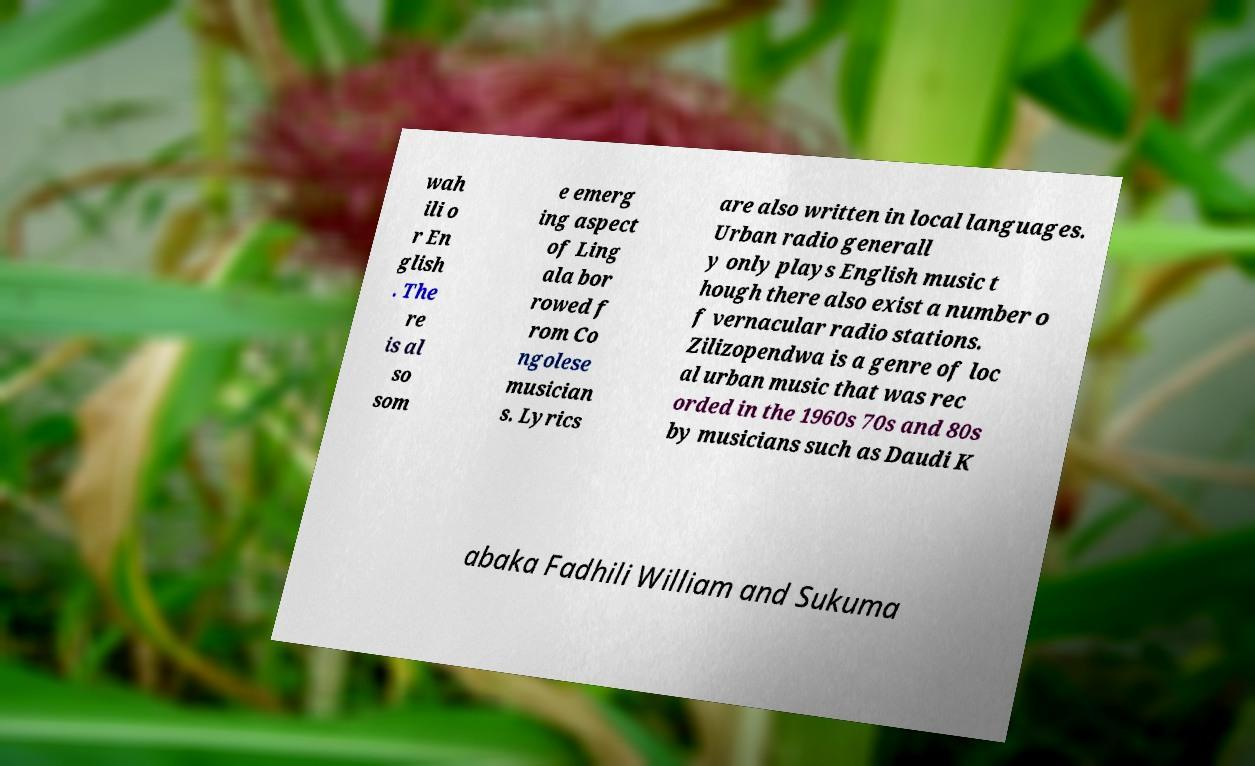What messages or text are displayed in this image? I need them in a readable, typed format. wah ili o r En glish . The re is al so som e emerg ing aspect of Ling ala bor rowed f rom Co ngolese musician s. Lyrics are also written in local languages. Urban radio generall y only plays English music t hough there also exist a number o f vernacular radio stations. Zilizopendwa is a genre of loc al urban music that was rec orded in the 1960s 70s and 80s by musicians such as Daudi K abaka Fadhili William and Sukuma 